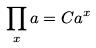Convert formula to latex. <formula><loc_0><loc_0><loc_500><loc_500>\prod _ { x } a = C a ^ { x }</formula> 